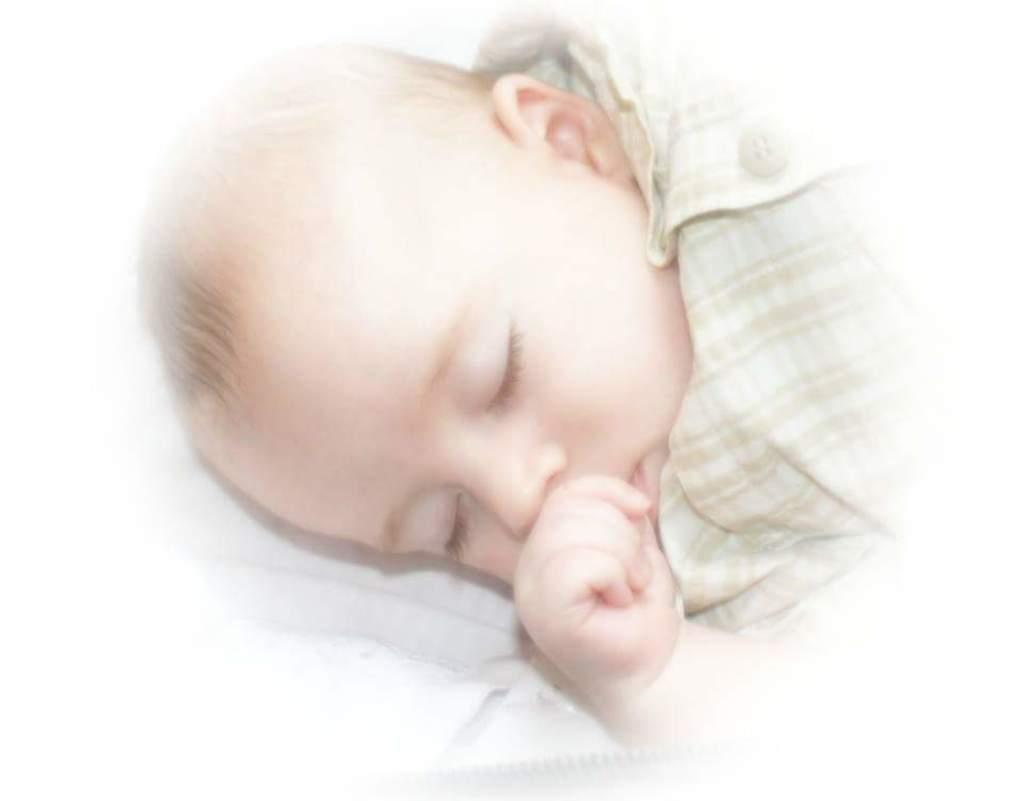What is the main subject of the picture? The main subject of the picture is a baby. What is the baby doing in the picture? The baby is sleeping. What type of plants can be seen growing near the baby in the picture? There are no plants visible in the picture; it only features a baby who is sleeping. How many generations away is the baby's grandmother from the baby in the picture? There is no information about the baby's grandmother in the picture, so it is impossible to determine the generational distance. 